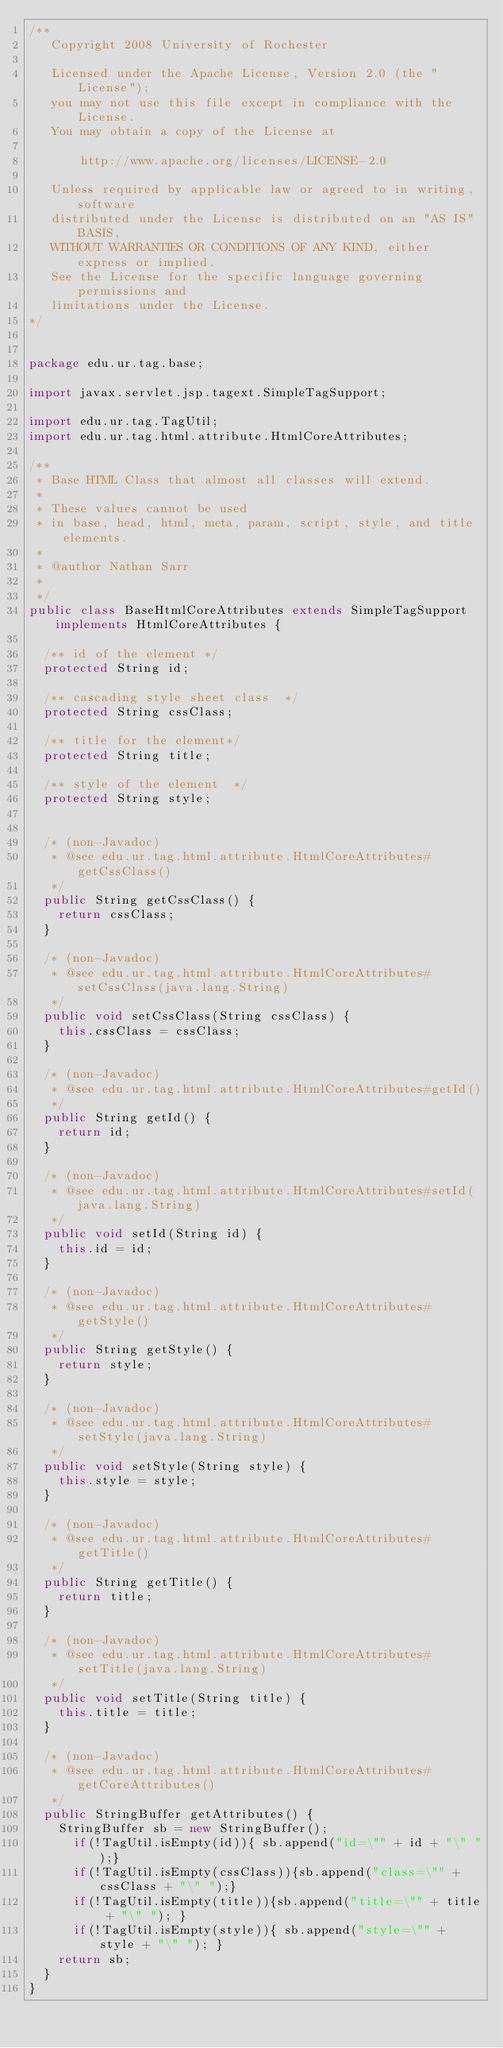Convert code to text. <code><loc_0><loc_0><loc_500><loc_500><_Java_>/**  
   Copyright 2008 University of Rochester

   Licensed under the Apache License, Version 2.0 (the "License");
   you may not use this file except in compliance with the License.
   You may obtain a copy of the License at

       http://www.apache.org/licenses/LICENSE-2.0

   Unless required by applicable law or agreed to in writing, software
   distributed under the License is distributed on an "AS IS" BASIS,
   WITHOUT WARRANTIES OR CONDITIONS OF ANY KIND, either express or implied.
   See the License for the specific language governing permissions and
   limitations under the License.
*/  


package edu.ur.tag.base;

import javax.servlet.jsp.tagext.SimpleTagSupport;

import edu.ur.tag.TagUtil;
import edu.ur.tag.html.attribute.HtmlCoreAttributes;

/**
 * Base HTML Class that almost all classes will extend.
 * 
 * These values cannot be used 
 * in base, head, html, meta, param, script, style, and title elements.
 * 
 * @author Nathan Sarr
 *
 */
public class BaseHtmlCoreAttributes extends SimpleTagSupport implements HtmlCoreAttributes {

	/** id of the element */
	protected String id;
	
	/** cascading style sheet class  */
	protected String cssClass; 

	/** title for the element*/
	protected String title;
	
	/** style of the element  */
	protected String style;
	
	
	/* (non-Javadoc)
	 * @see edu.ur.tag.html.attribute.HtmlCoreAttributes#getCssClass()
	 */
	public String getCssClass() {
		return cssClass;
	}
	
	/* (non-Javadoc)
	 * @see edu.ur.tag.html.attribute.HtmlCoreAttributes#setCssClass(java.lang.String)
	 */
	public void setCssClass(String cssClass) {
		this.cssClass = cssClass;
	}
	
	/* (non-Javadoc)
	 * @see edu.ur.tag.html.attribute.HtmlCoreAttributes#getId()
	 */
	public String getId() {
		return id;
	}
	
	/* (non-Javadoc)
	 * @see edu.ur.tag.html.attribute.HtmlCoreAttributes#setId(java.lang.String)
	 */
	public void setId(String id) {
		this.id = id;
	}
	
	/* (non-Javadoc)
	 * @see edu.ur.tag.html.attribute.HtmlCoreAttributes#getStyle()
	 */
	public String getStyle() {
		return style;
	}
	
	/* (non-Javadoc)
	 * @see edu.ur.tag.html.attribute.HtmlCoreAttributes#setStyle(java.lang.String)
	 */
	public void setStyle(String style) {
		this.style = style;
	}
	
	/* (non-Javadoc)
	 * @see edu.ur.tag.html.attribute.HtmlCoreAttributes#getTitle()
	 */
	public String getTitle() {
		return title;
	}
	
	/* (non-Javadoc)
	 * @see edu.ur.tag.html.attribute.HtmlCoreAttributes#setTitle(java.lang.String)
	 */
	public void setTitle(String title) {
		this.title = title;
	}
	
	/* (non-Javadoc)
	 * @see edu.ur.tag.html.attribute.HtmlCoreAttributes#getCoreAttributes()
	 */
	public StringBuffer getAttributes() {
		StringBuffer sb = new StringBuffer();
    	if(!TagUtil.isEmpty(id)){ sb.append("id=\"" + id + "\" ");}  
    	if(!TagUtil.isEmpty(cssClass)){sb.append("class=\"" + cssClass + "\" ");}  
    	if(!TagUtil.isEmpty(title)){sb.append("title=\"" + title + "\" "); }  
    	if(!TagUtil.isEmpty(style)){ sb.append("style=\"" + style + "\" "); }  
		return sb;
	}
}
</code> 